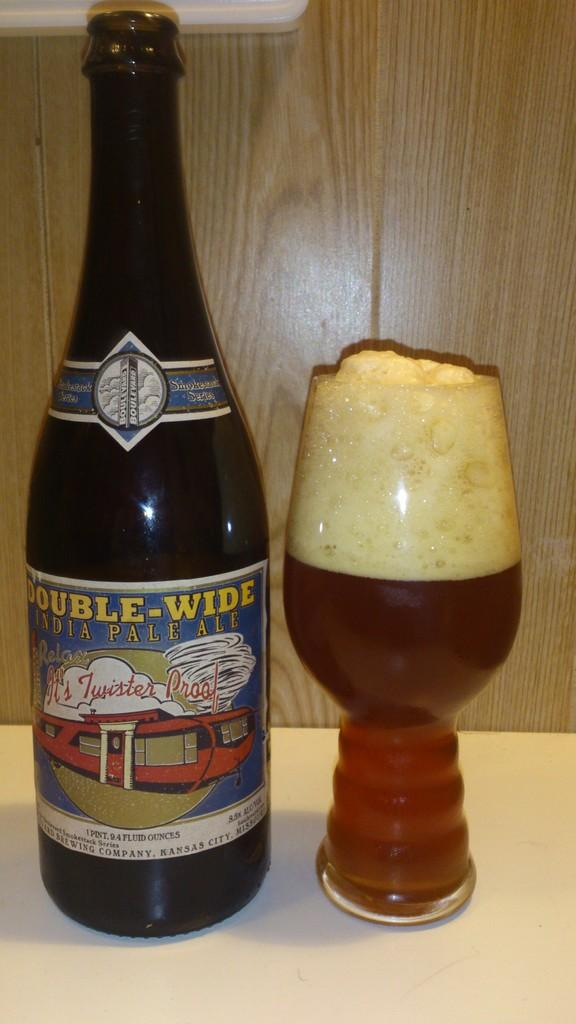What is in the bottle that is visible in the image? There is a bottle with a label in the image. What is in the glass that is visible in the image? There is a glass with a drink in the image. What type of material can be seen in the background of the image? There is a wooden wall in the background of the image. How does the hand balance the sugar in the image? There is no hand or sugar present in the image. 